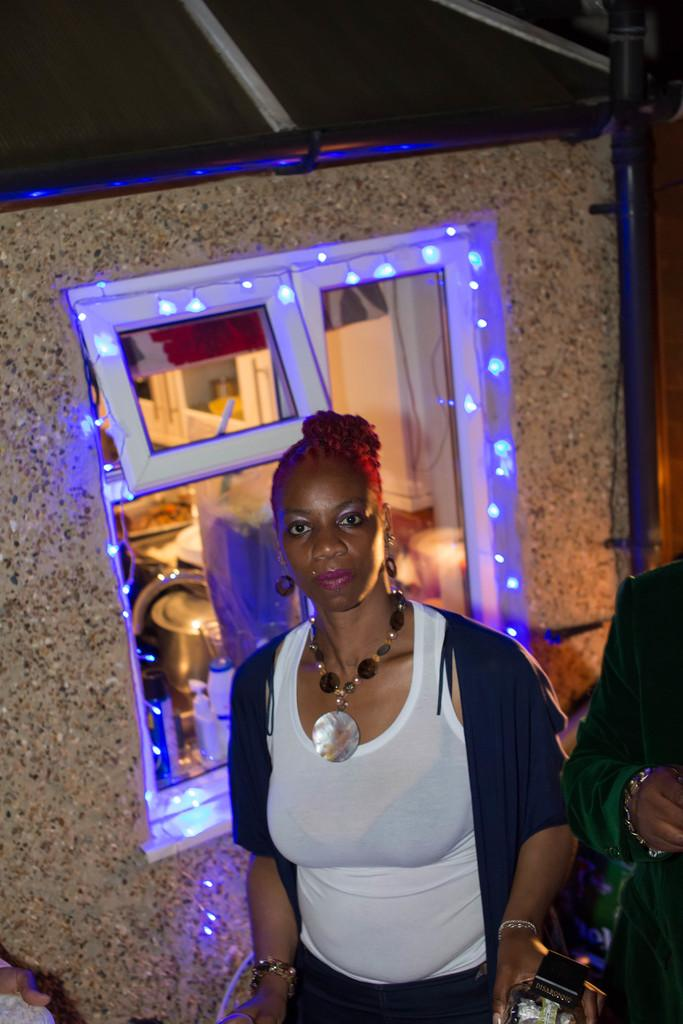What is the person in the image wearing? The person in the image is wearing a black and white dress. What can be seen in the background of the image? There is a wall in the image. How many people are present in the image? There are people in the image. What architectural features are visible in the image? There are windows in the image. What type of lighting is present in the image? There are lights in the image. What other objects can be seen in the image? There are other objects in the image. What type of patch can be seen on the fowl in the image? There is no fowl or patch present in the image. 